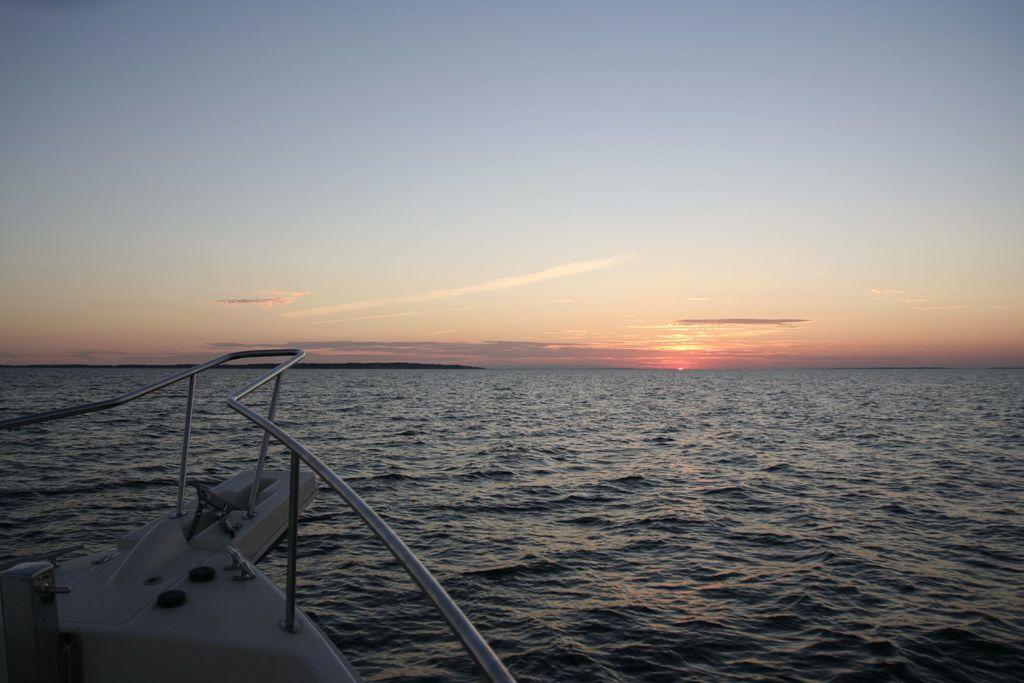What is the main subject of the image? There is a boat in the image. What can be seen in the background of the image? There is water and the sky visible in the background of the image. What type of current can be seen in the water near the boat? There is no current visible in the water near the boat; the water appears to be still. What type of engine is powering the boat in the image? The image does not provide any information about the engine powering the boat, so it cannot be determined from the image. 